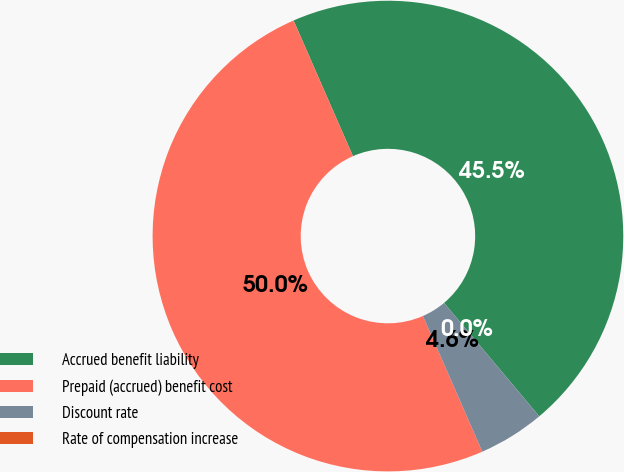Convert chart. <chart><loc_0><loc_0><loc_500><loc_500><pie_chart><fcel>Accrued benefit liability<fcel>Prepaid (accrued) benefit cost<fcel>Discount rate<fcel>Rate of compensation increase<nl><fcel>45.45%<fcel>50.0%<fcel>4.55%<fcel>0.0%<nl></chart> 